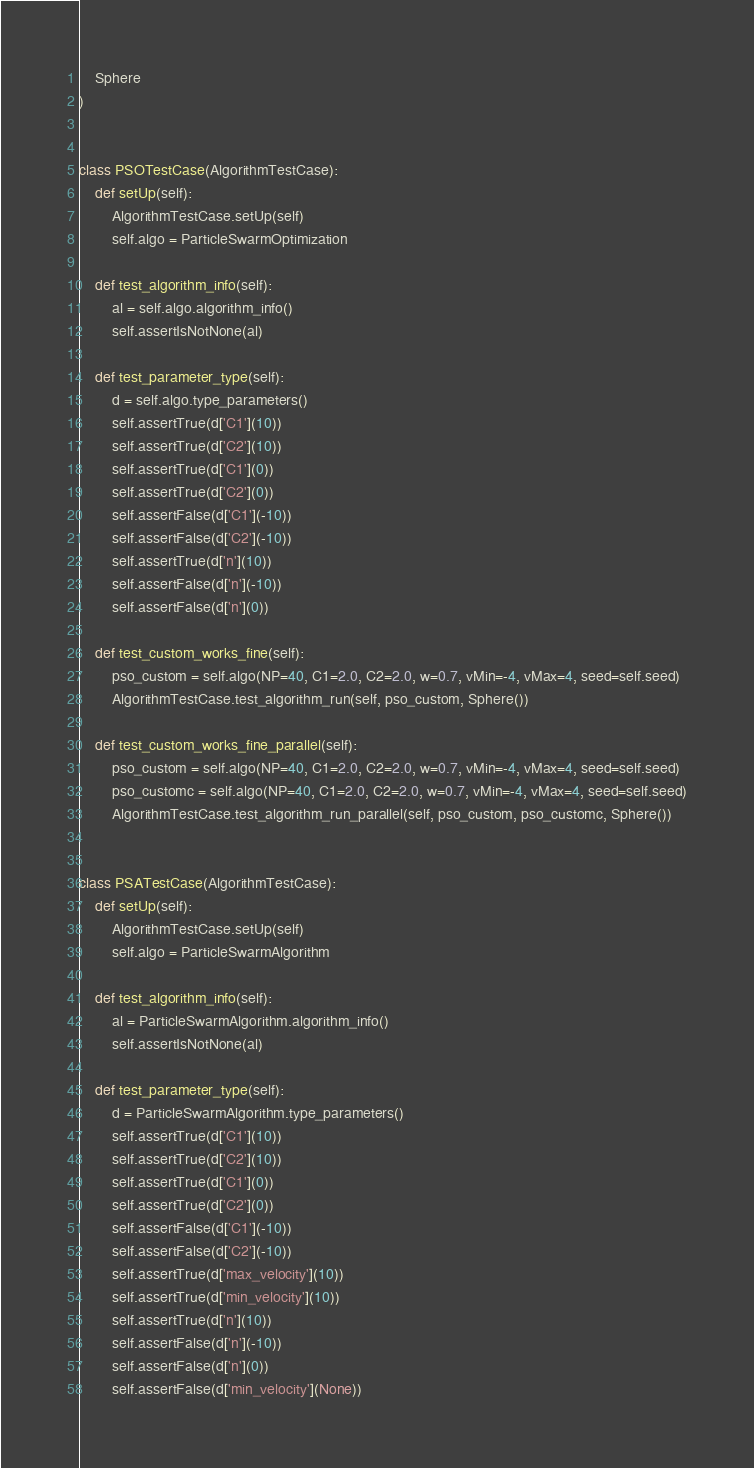Convert code to text. <code><loc_0><loc_0><loc_500><loc_500><_Python_>	Sphere
)


class PSOTestCase(AlgorithmTestCase):
	def setUp(self):
		AlgorithmTestCase.setUp(self)
		self.algo = ParticleSwarmOptimization

	def test_algorithm_info(self):
		al = self.algo.algorithm_info()
		self.assertIsNotNone(al)

	def test_parameter_type(self):
		d = self.algo.type_parameters()
		self.assertTrue(d['C1'](10))
		self.assertTrue(d['C2'](10))
		self.assertTrue(d['C1'](0))
		self.assertTrue(d['C2'](0))
		self.assertFalse(d['C1'](-10))
		self.assertFalse(d['C2'](-10))
		self.assertTrue(d['n'](10))
		self.assertFalse(d['n'](-10))
		self.assertFalse(d['n'](0))

	def test_custom_works_fine(self):
		pso_custom = self.algo(NP=40, C1=2.0, C2=2.0, w=0.7, vMin=-4, vMax=4, seed=self.seed)
		AlgorithmTestCase.test_algorithm_run(self, pso_custom, Sphere())

	def test_custom_works_fine_parallel(self):
		pso_custom = self.algo(NP=40, C1=2.0, C2=2.0, w=0.7, vMin=-4, vMax=4, seed=self.seed)
		pso_customc = self.algo(NP=40, C1=2.0, C2=2.0, w=0.7, vMin=-4, vMax=4, seed=self.seed)
		AlgorithmTestCase.test_algorithm_run_parallel(self, pso_custom, pso_customc, Sphere())


class PSATestCase(AlgorithmTestCase):
	def setUp(self):
		AlgorithmTestCase.setUp(self)
		self.algo = ParticleSwarmAlgorithm

	def test_algorithm_info(self):
		al = ParticleSwarmAlgorithm.algorithm_info()
		self.assertIsNotNone(al)

	def test_parameter_type(self):
		d = ParticleSwarmAlgorithm.type_parameters()
		self.assertTrue(d['C1'](10))
		self.assertTrue(d['C2'](10))
		self.assertTrue(d['C1'](0))
		self.assertTrue(d['C2'](0))
		self.assertFalse(d['C1'](-10))
		self.assertFalse(d['C2'](-10))
		self.assertTrue(d['max_velocity'](10))
		self.assertTrue(d['min_velocity'](10))
		self.assertTrue(d['n'](10))
		self.assertFalse(d['n'](-10))
		self.assertFalse(d['n'](0))
		self.assertFalse(d['min_velocity'](None))</code> 